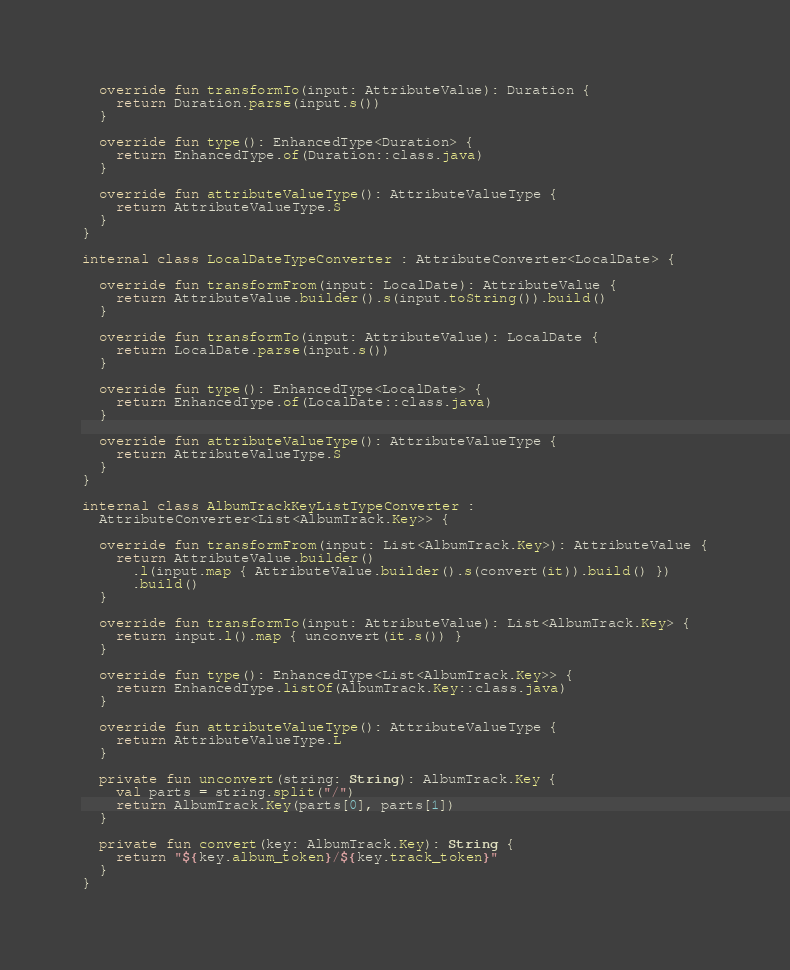<code> <loc_0><loc_0><loc_500><loc_500><_Kotlin_>  override fun transformTo(input: AttributeValue): Duration {
    return Duration.parse(input.s())
  }

  override fun type(): EnhancedType<Duration> {
    return EnhancedType.of(Duration::class.java)
  }

  override fun attributeValueType(): AttributeValueType {
    return AttributeValueType.S
  }
}

internal class LocalDateTypeConverter : AttributeConverter<LocalDate> {

  override fun transformFrom(input: LocalDate): AttributeValue {
    return AttributeValue.builder().s(input.toString()).build()
  }

  override fun transformTo(input: AttributeValue): LocalDate {
    return LocalDate.parse(input.s())
  }

  override fun type(): EnhancedType<LocalDate> {
    return EnhancedType.of(LocalDate::class.java)
  }

  override fun attributeValueType(): AttributeValueType {
    return AttributeValueType.S
  }
}

internal class AlbumTrackKeyListTypeConverter :
  AttributeConverter<List<AlbumTrack.Key>> {

  override fun transformFrom(input: List<AlbumTrack.Key>): AttributeValue {
    return AttributeValue.builder()
      .l(input.map { AttributeValue.builder().s(convert(it)).build() })
      .build()
  }

  override fun transformTo(input: AttributeValue): List<AlbumTrack.Key> {
    return input.l().map { unconvert(it.s()) }
  }

  override fun type(): EnhancedType<List<AlbumTrack.Key>> {
    return EnhancedType.listOf(AlbumTrack.Key::class.java)
  }

  override fun attributeValueType(): AttributeValueType {
    return AttributeValueType.L
  }

  private fun unconvert(string: String): AlbumTrack.Key {
    val parts = string.split("/")
    return AlbumTrack.Key(parts[0], parts[1])
  }

  private fun convert(key: AlbumTrack.Key): String {
    return "${key.album_token}/${key.track_token}"
  }
}
</code> 